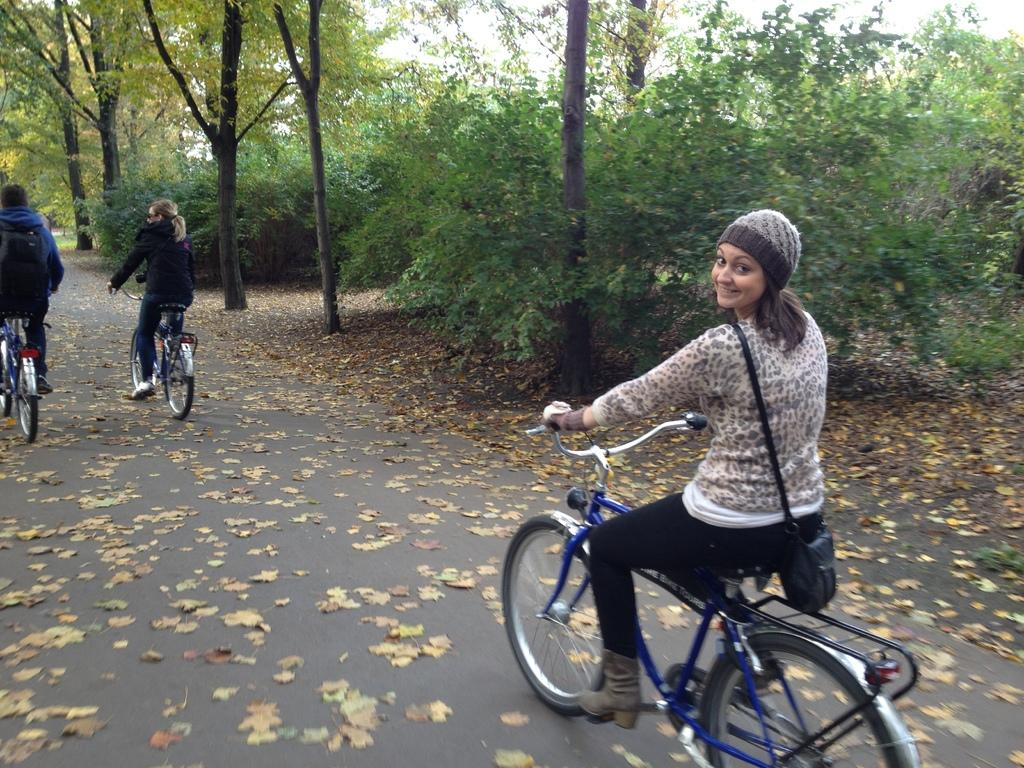What are the people in the image doing? The people in the image are riding bicycles. Can you describe the woman's attire in the image? The woman is wearing a cap on her head and a bag. What type of vegetation can be seen in the image? There are trees visible in the image. What is present on the ground in the image? There are leaves on the ground in the image. What type of cake is the woman holding in the image? There is no cake present in the image; the woman is wearing a bag. How many oranges are visible on the trees in the image? There are no oranges visible in the image; only trees and leaves are present on the ground. 